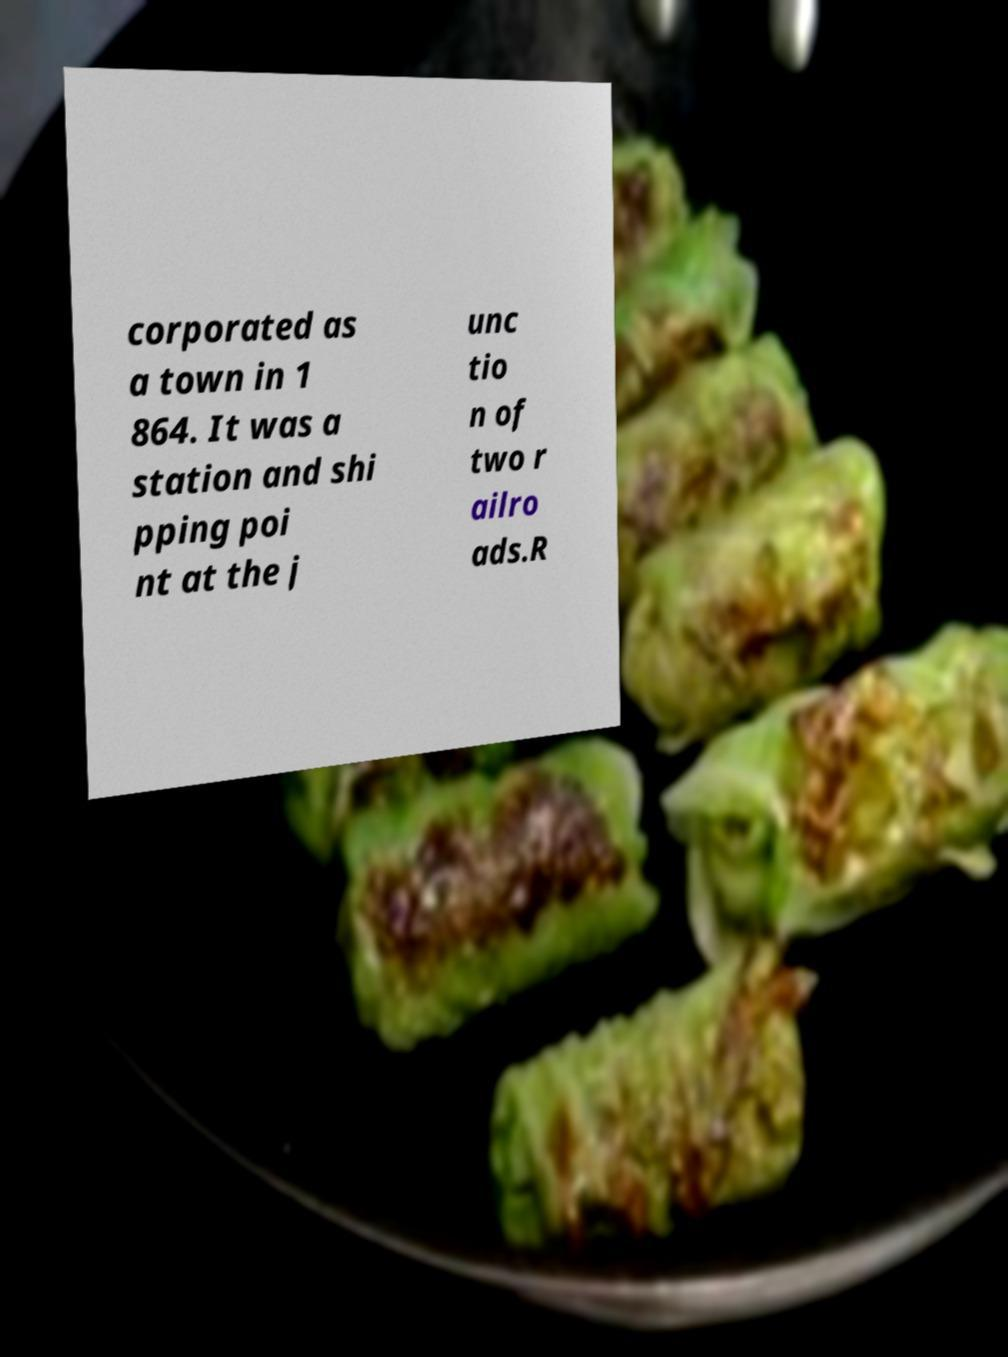What messages or text are displayed in this image? I need them in a readable, typed format. corporated as a town in 1 864. It was a station and shi pping poi nt at the j unc tio n of two r ailro ads.R 